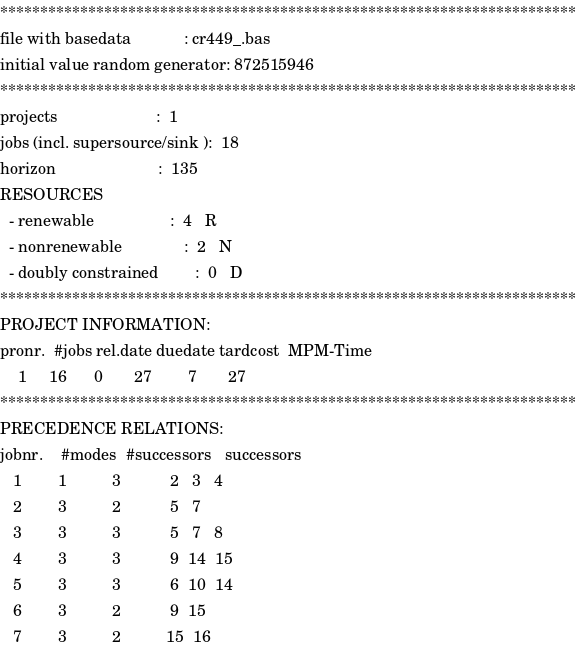Convert code to text. <code><loc_0><loc_0><loc_500><loc_500><_ObjectiveC_>************************************************************************
file with basedata            : cr449_.bas
initial value random generator: 872515946
************************************************************************
projects                      :  1
jobs (incl. supersource/sink ):  18
horizon                       :  135
RESOURCES
  - renewable                 :  4   R
  - nonrenewable              :  2   N
  - doubly constrained        :  0   D
************************************************************************
PROJECT INFORMATION:
pronr.  #jobs rel.date duedate tardcost  MPM-Time
    1     16      0       27        7       27
************************************************************************
PRECEDENCE RELATIONS:
jobnr.    #modes  #successors   successors
   1        1          3           2   3   4
   2        3          2           5   7
   3        3          3           5   7   8
   4        3          3           9  14  15
   5        3          3           6  10  14
   6        3          2           9  15
   7        3          2          15  16</code> 